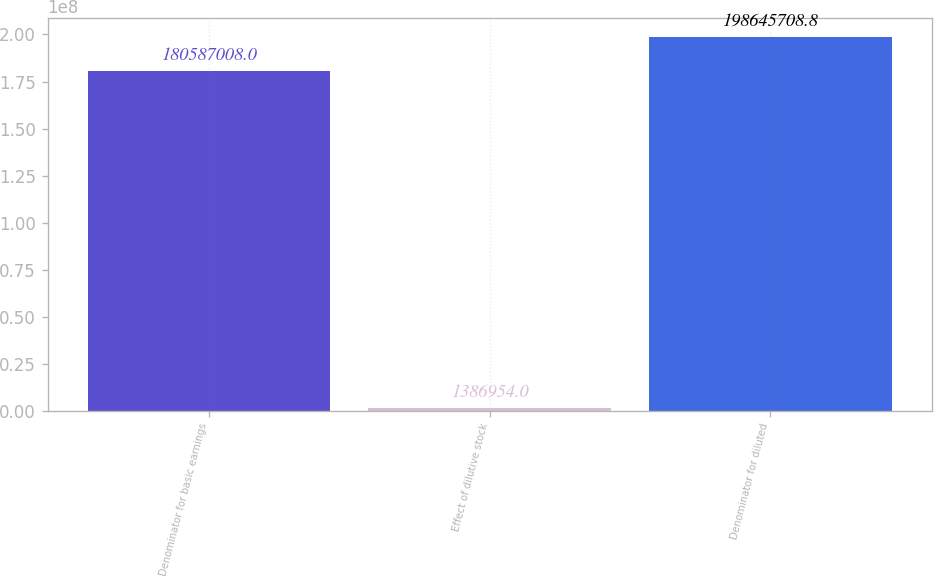<chart> <loc_0><loc_0><loc_500><loc_500><bar_chart><fcel>Denominator for basic earnings<fcel>Effect of dilutive stock<fcel>Denominator for diluted<nl><fcel>1.80587e+08<fcel>1.38695e+06<fcel>1.98646e+08<nl></chart> 